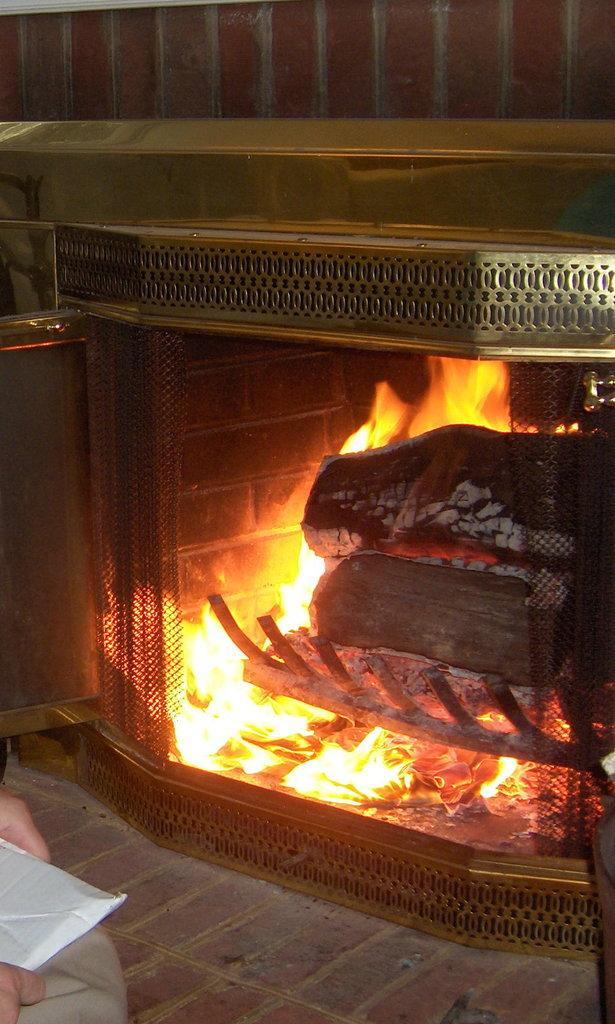What is the object being held with hands in the image? The information provided does not specify the object being held, so we cannot determine its identity. What is the source of the flame in the image? The information provided does not specify the source of the flame, so we cannot determine its origin. What is the material of the object being held in the image? The information provided does not specify the material of the object being held, so we cannot determine its composition. What is the purpose of the wall in the image? The information provided does not specify the purpose of the wall, so we cannot determine its function. What type of doll is being bitten by the object in the image? There is no doll present in the image, and no object is shown biting anything. 